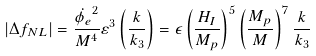<formula> <loc_0><loc_0><loc_500><loc_500>| \Delta f _ { N L } | = \frac { \dot { \phi _ { e } } ^ { 2 } } { M ^ { 4 } } \varepsilon ^ { 3 } \left ( \frac { k } { k _ { 3 } } \right ) = \epsilon \left ( \frac { H _ { I } } { M _ { p } } \right ) ^ { 5 } \left ( \frac { M _ { p } } { M } \right ) ^ { 7 } \frac { k } { k _ { 3 } }</formula> 